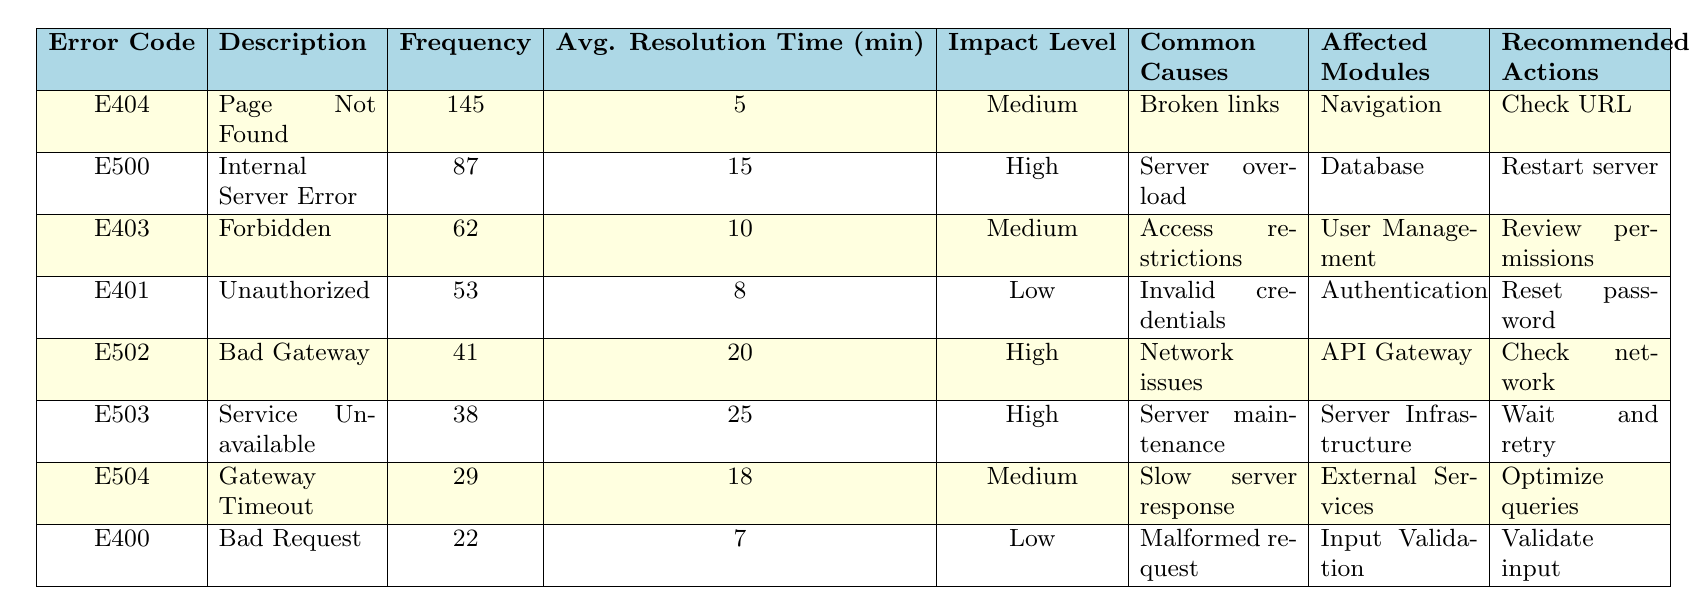What is the error code for "Page Not Found"? The table shows that the description "Page Not Found" corresponds to the error code "E404".
Answer: E404 Which error code has the highest frequency? From the table, "E404" has the highest frequency at 145 occurrences, compared to others.
Answer: E404 What is the average resolution time for "Internal Server Error"? The table indicates that the average resolution time for the error code "E500" (Internal Server Error) is 15 minutes.
Answer: 15 minutes How many errors have a user impact level of "High"? By examining the user impact level column, the error codes E500, E502, and E503 have a "High" impact level, totaling 3 errors.
Answer: 3 What is the total frequency of all errors combined? Calculating the total frequency involves summing the frequencies of all error codes: 145 + 87 + 62 + 53 + 41 + 38 + 29 + 22 = 477.
Answer: 477 What is the error code with the longest average resolution time? Looking at the average resolution time, "E503" has the longest at 25 minutes.
Answer: E503 Is there an error code that corresponds to "Invalid credentials"? Yes, the error description "Invalid credentials" corresponds to the error code "E401" in the table.
Answer: Yes What is the relationship between error codes E400 and E404 in terms of average resolution time? The average resolution time for "E400" is 7 minutes while for "E404" it is 5 minutes, showing that E400 takes 2 more minutes on average to resolve than E404.
Answer: E400 takes longer by 2 minutes What common causes lead to the "Service Unavailable" error? The table states that "Service Unavailable," designated by error code "E503," has the common cause "Server maintenance."
Answer: Server maintenance Which error code has the lowest frequency and what is its impact level? The lowest frequency is for error code "E400," with 22 occurrences, which has a "Low" impact level.
Answer: E400, Low impact level 